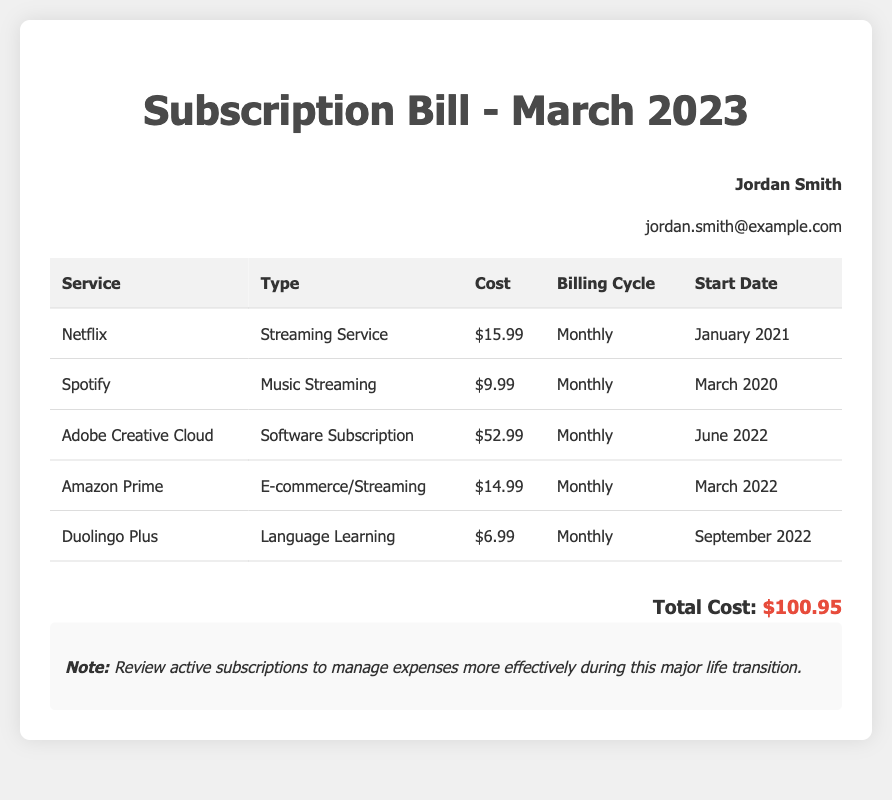What is the total cost of all subscriptions? The total cost is listed at the bottom of the document, which sums up all the individual subscription costs.
Answer: $100.95 How many active memberships are listed? The document lists five different active memberships in the table.
Answer: 5 What is the cost of Adobe Creative Cloud? The specific cost of Adobe Creative Cloud is provided in the table under the "Cost" column.
Answer: $52.99 When did the Spotify subscription start? The start date for the Spotify subscription is stated in the table, showing when the service began.
Answer: March 2020 What type of service is Duolingo Plus? The type of service is mentioned in the "Type" column of the table detailing the subscriptions.
Answer: Language Learning What is the billing cycle for Amazon Prime? The billing cycle is indicated in the table for each subscription after the service name.
Answer: Monthly Which subscription has the highest cost? By comparing the costs provided, the highest subscription cost can be identified from the list.
Answer: Adobe Creative Cloud Which service has a start date in 2021? The start date of services is informative; by looking at the years, one can identify the specific service starting in 2021.
Answer: Netflix What is the email address of the user? The user's email is displayed under the user information section in the document.
Answer: jordan.smith@example.com 